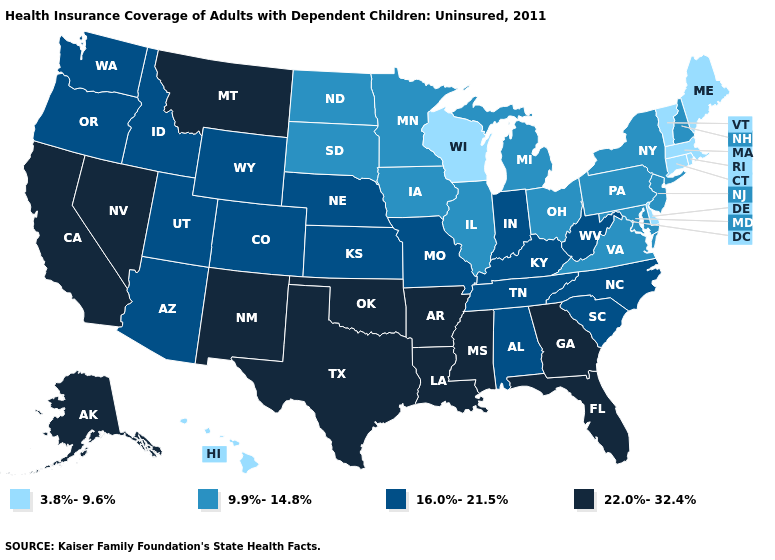What is the lowest value in states that border West Virginia?
Be succinct. 9.9%-14.8%. Name the states that have a value in the range 16.0%-21.5%?
Short answer required. Alabama, Arizona, Colorado, Idaho, Indiana, Kansas, Kentucky, Missouri, Nebraska, North Carolina, Oregon, South Carolina, Tennessee, Utah, Washington, West Virginia, Wyoming. Name the states that have a value in the range 9.9%-14.8%?
Short answer required. Illinois, Iowa, Maryland, Michigan, Minnesota, New Hampshire, New Jersey, New York, North Dakota, Ohio, Pennsylvania, South Dakota, Virginia. Among the states that border Kansas , does Missouri have the highest value?
Short answer required. No. How many symbols are there in the legend?
Write a very short answer. 4. Among the states that border West Virginia , which have the lowest value?
Answer briefly. Maryland, Ohio, Pennsylvania, Virginia. Does the first symbol in the legend represent the smallest category?
Keep it brief. Yes. What is the value of Texas?
Give a very brief answer. 22.0%-32.4%. Among the states that border Iowa , which have the lowest value?
Give a very brief answer. Wisconsin. Name the states that have a value in the range 3.8%-9.6%?
Concise answer only. Connecticut, Delaware, Hawaii, Maine, Massachusetts, Rhode Island, Vermont, Wisconsin. Name the states that have a value in the range 9.9%-14.8%?
Be succinct. Illinois, Iowa, Maryland, Michigan, Minnesota, New Hampshire, New Jersey, New York, North Dakota, Ohio, Pennsylvania, South Dakota, Virginia. Does New Hampshire have the highest value in the Northeast?
Keep it brief. Yes. What is the value of Illinois?
Answer briefly. 9.9%-14.8%. 